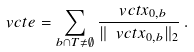<formula> <loc_0><loc_0><loc_500><loc_500>\ v c t { e } = \sum _ { b \cap T \neq \emptyset } \frac { \ v c t { x } _ { 0 , b } } { \| \ v c t { x } _ { 0 , b } \| _ { 2 } } \, .</formula> 